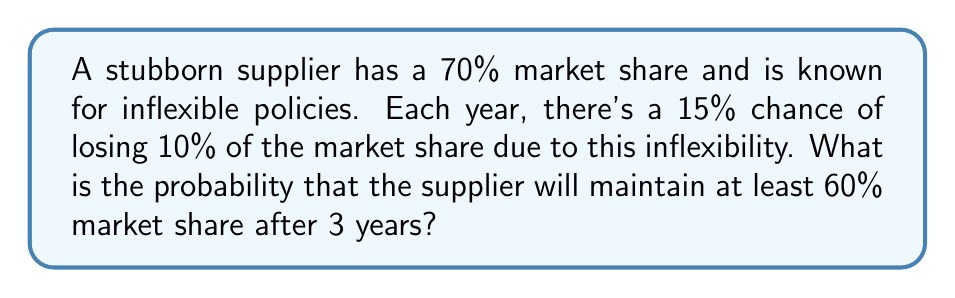Give your solution to this math problem. Let's approach this step-by-step:

1) First, we need to calculate the probability of not losing market share in a given year:
   $P(\text{not losing}) = 1 - 0.15 = 0.85$

2) To maintain at least 60% market share, the supplier can afford to lose market share at most once in 3 years. The scenarios are:
   a) No loss in 3 years
   b) Loss in exactly 1 year out of 3

3) Probability of no loss in 3 years:
   $P(\text{no loss}) = 0.85^3 = 0.614125$

4) Probability of loss in exactly 1 year:
   $P(\text{1 loss}) = \binom{3}{1} \times 0.15 \times 0.85^2 = 3 \times 0.15 \times 0.7225 = 0.325125$

5) The total probability is the sum of these two scenarios:
   $P(\text{maintaining} \geq 60\%) = P(\text{no loss}) + P(\text{1 loss})$
   $= 0.614125 + 0.325125 = 0.93925$

Therefore, the probability of maintaining at least 60% market share after 3 years is approximately 0.93925 or 93.925%.
Answer: $$P(\text{maintaining} \geq 60\% \text{ market share after 3 years}) \approx 0.93925 \text{ or } 93.925\%$$ 